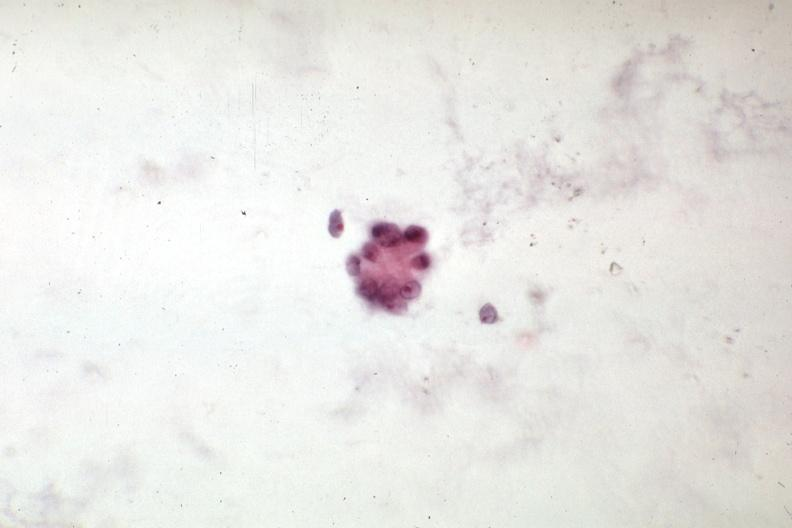what does this image show?
Answer the question using a single word or phrase. Malignant cells mixed mesodermal tumor of uterus 